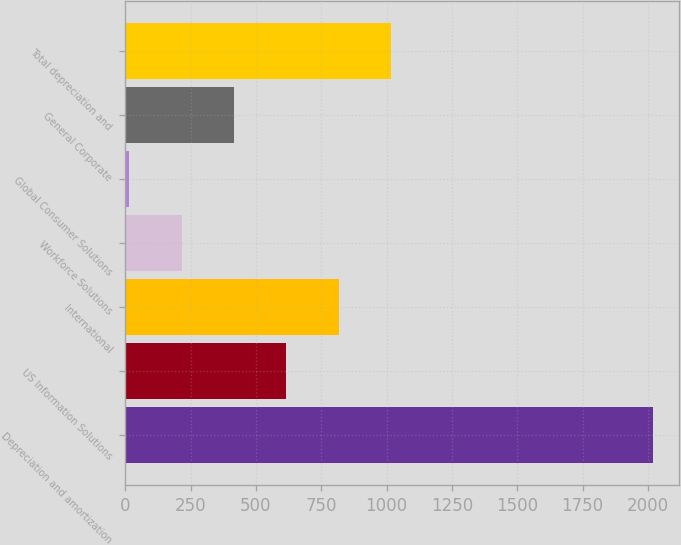Convert chart to OTSL. <chart><loc_0><loc_0><loc_500><loc_500><bar_chart><fcel>Depreciation and amortization<fcel>US Information Solutions<fcel>International<fcel>Workforce Solutions<fcel>Global Consumer Solutions<fcel>General Corporate<fcel>Total depreciation and<nl><fcel>2018<fcel>615.83<fcel>816.14<fcel>215.21<fcel>14.9<fcel>415.52<fcel>1016.45<nl></chart> 